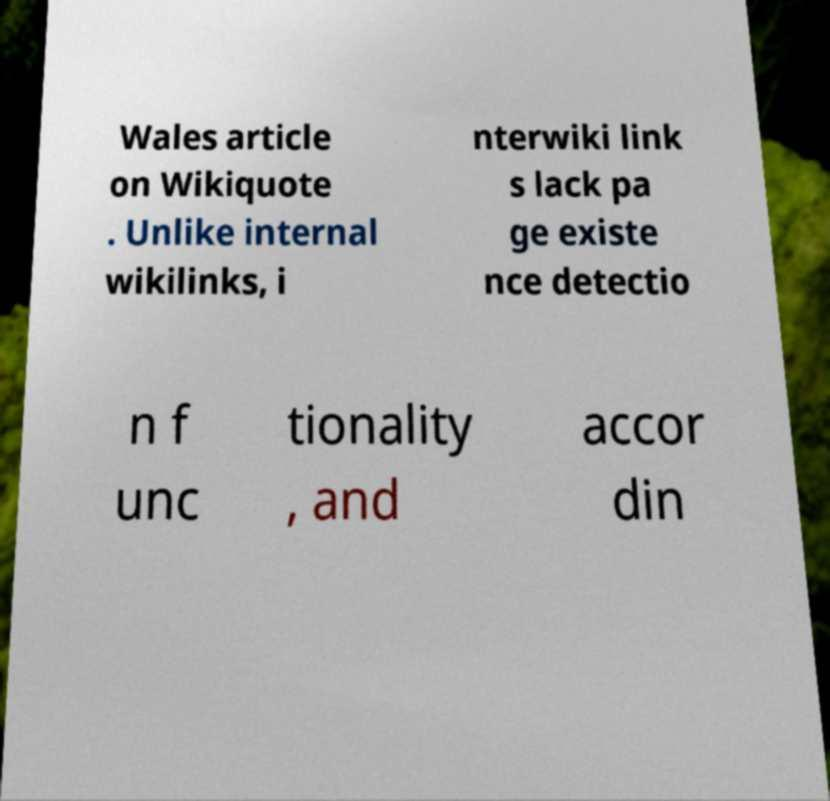Can you read and provide the text displayed in the image?This photo seems to have some interesting text. Can you extract and type it out for me? Wales article on Wikiquote . Unlike internal wikilinks, i nterwiki link s lack pa ge existe nce detectio n f unc tionality , and accor din 